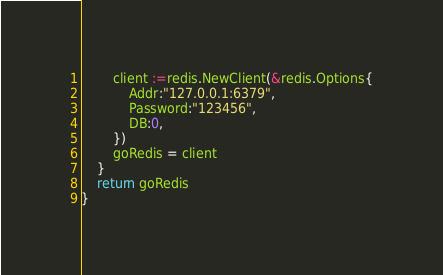Convert code to text. <code><loc_0><loc_0><loc_500><loc_500><_Go_>		client :=redis.NewClient(&redis.Options{
			Addr:"127.0.0.1:6379",
			Password:"123456",
			DB:0,
		})
		goRedis = client
	}
	return goRedis
}</code> 